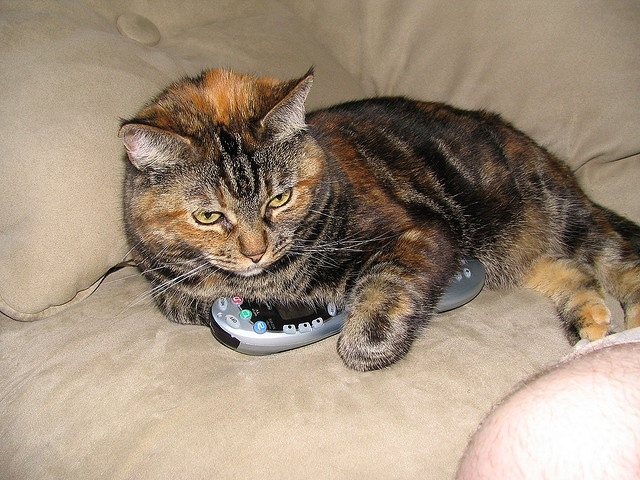Describe the objects in this image and their specific colors. I can see couch in gray and tan tones, cat in gray, black, and maroon tones, people in gray, white, and tan tones, and remote in gray, black, darkgray, and lightgray tones in this image. 